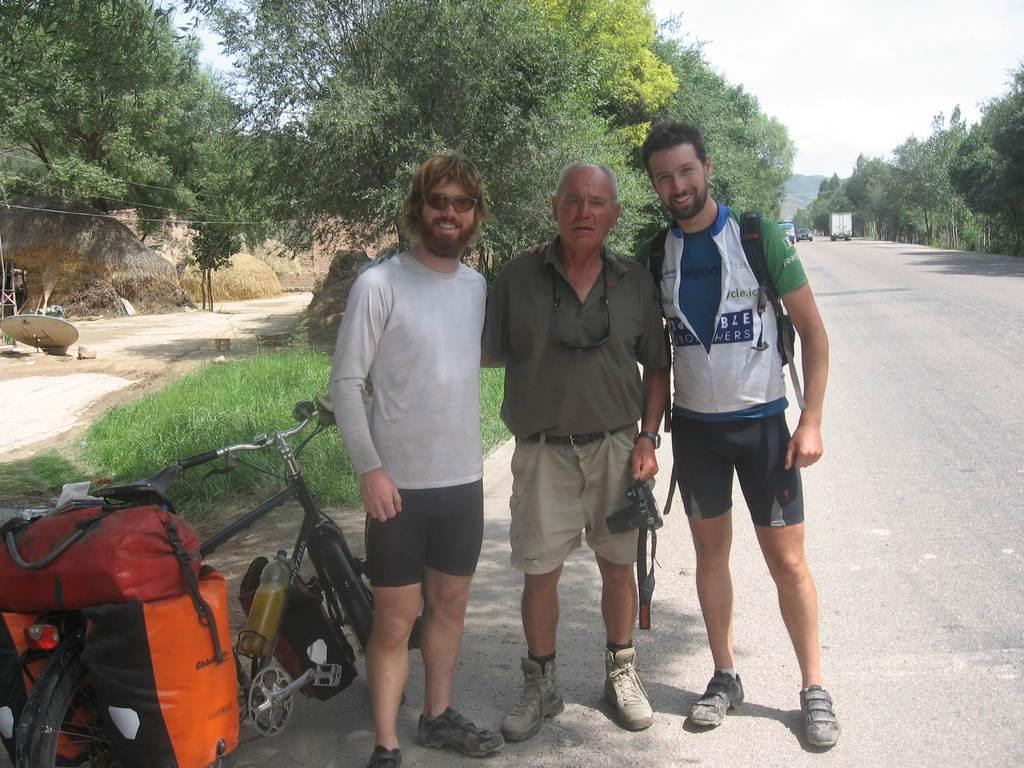How many people are standing on the road in the image? There are three men standing on the road in the image. What can be seen on either side of the road? There are trees on either side of the road. What type of vehicle is present on the left side of the road? There is a bicycle on the left side of the road. What type of class is being held on the road in the image? There is no class being held on the road in the image. What appliance can be seen ringing bells in the image? There are no appliances or bells present in the image. 